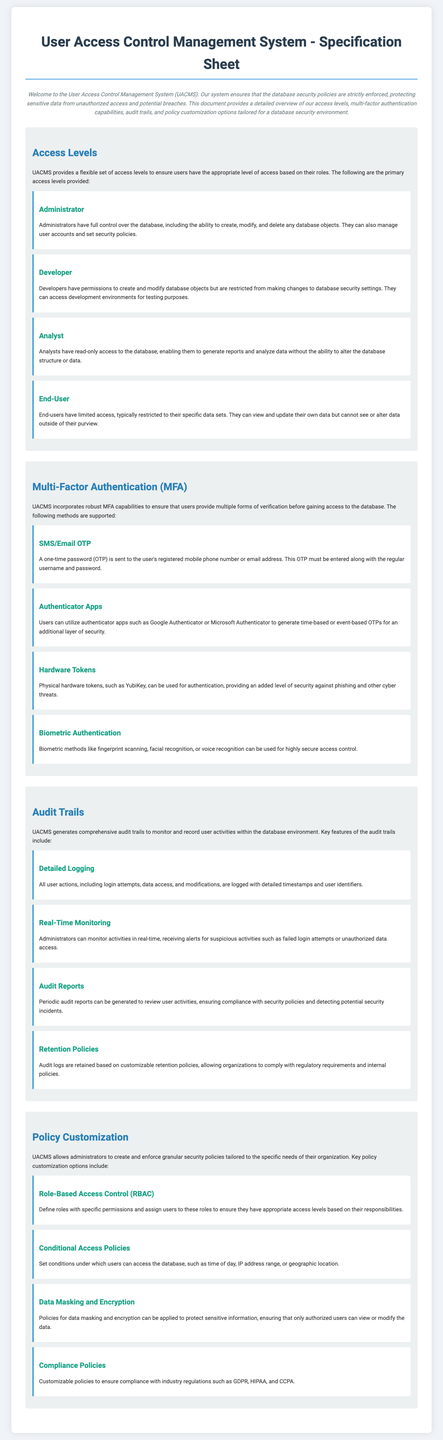What are the primary access levels provided by UACMS? The document lists four primary access levels for UACMS: Administrator, Developer, Analyst, and End-User.
Answer: Administrator, Developer, Analyst, End-User What is the authentication method that uses physical hardware tokens? The document describes the use of "Hardware Tokens" as a method of multi-factor authentication.
Answer: Hardware Tokens What type of access do Analysts have in UACMS? According to the document, Analysts have read-only access to the database, which allows them to generate reports and analyze data without making changes.
Answer: Read-only access What can administrators monitor in real-time? The document states that administrators can monitor activities and receive alerts for suspicious actions, such as failed login attempts or unauthorized data access.
Answer: Activities and alerts Which policy customization option ensures compliance with regulations like GDPR? The document mentions "Compliance Policies" as a key policy customization option aimed at ensuring regulatory compliance.
Answer: Compliance Policies How many methods of multi-factor authentication are described in the document? The document outlines four different methods of multi-factor authentication available in UACMS.
Answer: Four What is the purpose of audit trails in UACMS? The document explains that audit trails are generated to monitor and record user activities within the database environment.
Answer: Monitor and record user activities What element of UACMS determines access permissions based on user roles? The document specifies that Role-Based Access Control (RBAC) is used to define roles with specific permissions.
Answer: Role-Based Access Control (RBAC) 